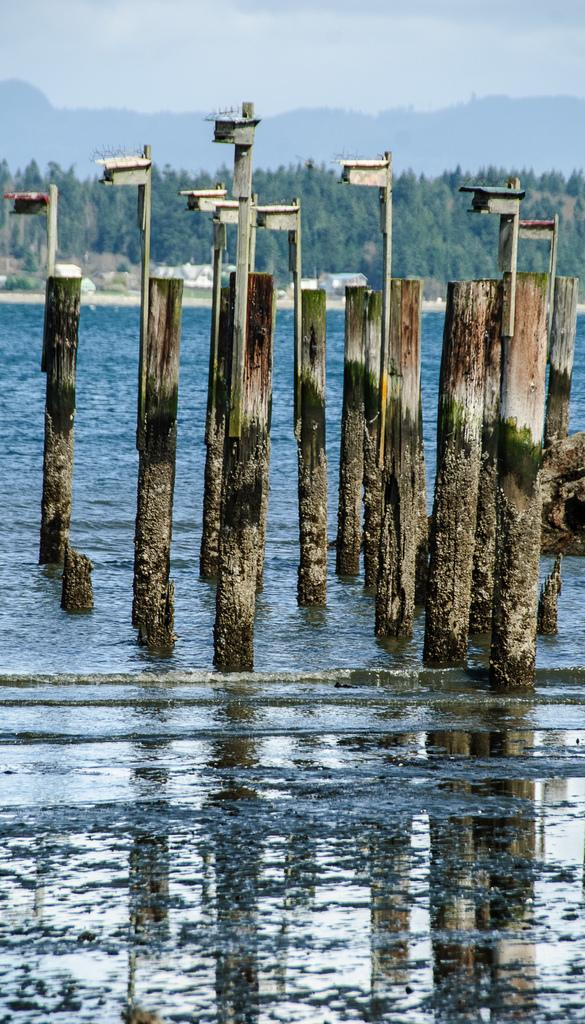What is the primary element in the image? There is water in the image. What objects can be seen in the water? There are wooden poles in the water. What can be seen in the background of the image? There are trees, stones, and mountains in the background of the image. What part of the natural environment is visible in the image? The sky is visible in the image. What type of lace can be seen on the mountains in the image? There is no lace present on the mountains in the image. What emotion can be seen on the faces of the trees in the image? There are no faces or emotions present on the trees in the image. 